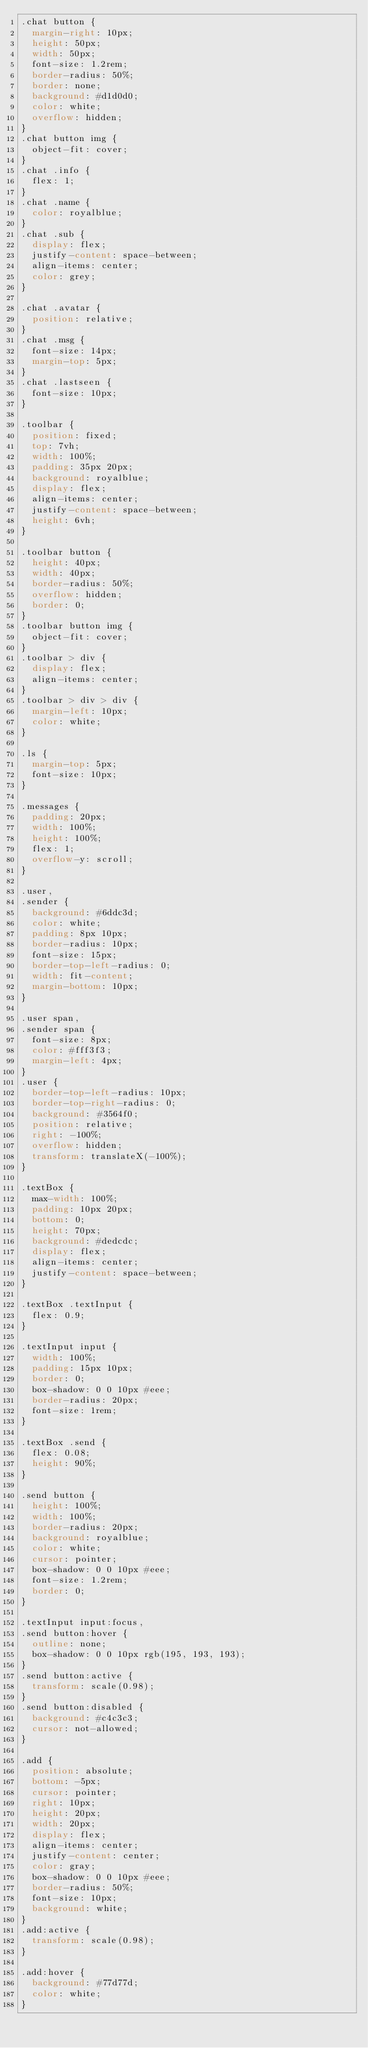<code> <loc_0><loc_0><loc_500><loc_500><_CSS_>.chat button {
  margin-right: 10px;
  height: 50px;
  width: 50px;
  font-size: 1.2rem;
  border-radius: 50%;
  border: none;
  background: #d1d0d0;
  color: white;
  overflow: hidden;
}
.chat button img {
  object-fit: cover;
}
.chat .info {
  flex: 1;
}
.chat .name {
  color: royalblue;
}
.chat .sub {
  display: flex;
  justify-content: space-between;
  align-items: center;
  color: grey;
}

.chat .avatar {
  position: relative;
}
.chat .msg {
  font-size: 14px;
  margin-top: 5px;
}
.chat .lastseen {
  font-size: 10px;
}

.toolbar {
  position: fixed;
  top: 7vh;
  width: 100%;
  padding: 35px 20px;
  background: royalblue;
  display: flex;
  align-items: center;
  justify-content: space-between;
  height: 6vh;
}

.toolbar button {
  height: 40px;
  width: 40px;
  border-radius: 50%;
  overflow: hidden;
  border: 0;
}
.toolbar button img {
  object-fit: cover;
}
.toolbar > div {
  display: flex;
  align-items: center;
}
.toolbar > div > div {
  margin-left: 10px;
  color: white;
}

.ls {
  margin-top: 5px;
  font-size: 10px;
}

.messages {
  padding: 20px;
  width: 100%;
  height: 100%;
  flex: 1;
  overflow-y: scroll;
}

.user,
.sender {
  background: #6ddc3d;
  color: white;
  padding: 8px 10px;
  border-radius: 10px;
  font-size: 15px;
  border-top-left-radius: 0;
  width: fit-content;
  margin-bottom: 10px;
}

.user span,
.sender span {
  font-size: 8px;
  color: #fff3f3;
  margin-left: 4px;
}
.user {
  border-top-left-radius: 10px;
  border-top-right-radius: 0;
  background: #3564f0;
  position: relative;
  right: -100%;
  overflow: hidden;
  transform: translateX(-100%);
}

.textBox {
  max-width: 100%;
  padding: 10px 20px;
  bottom: 0;
  height: 70px;
  background: #dedcdc;
  display: flex;
  align-items: center;
  justify-content: space-between;
}

.textBox .textInput {
  flex: 0.9;
}

.textInput input {
  width: 100%;
  padding: 15px 10px;
  border: 0;
  box-shadow: 0 0 10px #eee;
  border-radius: 20px;
  font-size: 1rem;
}

.textBox .send {
  flex: 0.08;
  height: 90%;
}

.send button {
  height: 100%;
  width: 100%;
  border-radius: 20px;
  background: royalblue;
  color: white;
  cursor: pointer;
  box-shadow: 0 0 10px #eee;
  font-size: 1.2rem;
  border: 0;
}

.textInput input:focus,
.send button:hover {
  outline: none;
  box-shadow: 0 0 10px rgb(195, 193, 193);
}
.send button:active {
  transform: scale(0.98);
}
.send button:disabled {
  background: #c4c3c3;
  cursor: not-allowed;
}

.add {
  position: absolute;
  bottom: -5px;
  cursor: pointer;
  right: 10px;
  height: 20px;
  width: 20px;
  display: flex;
  align-items: center;
  justify-content: center;
  color: gray;
  box-shadow: 0 0 10px #eee;
  border-radius: 50%;
  font-size: 10px;
  background: white;
}
.add:active {
  transform: scale(0.98);
}

.add:hover {
  background: #77d77d;
  color: white;
}
</code> 